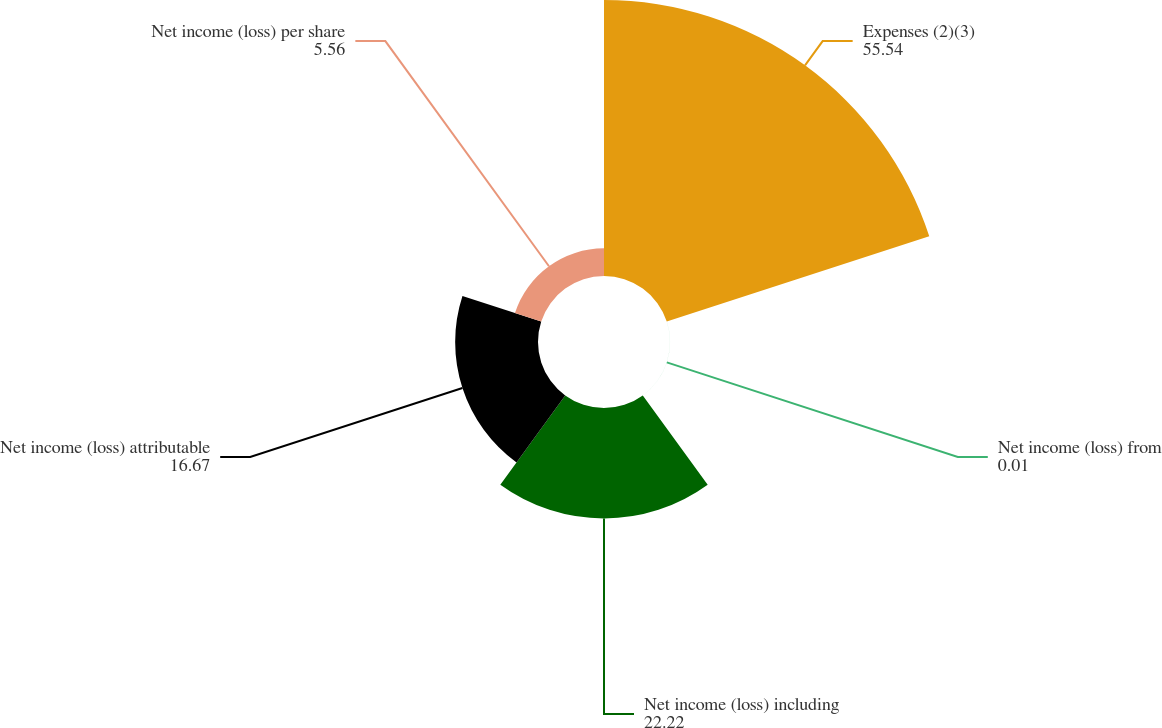Convert chart. <chart><loc_0><loc_0><loc_500><loc_500><pie_chart><fcel>Expenses (2)(3)<fcel>Net income (loss) from<fcel>Net income (loss) including<fcel>Net income (loss) attributable<fcel>Net income (loss) per share<nl><fcel>55.54%<fcel>0.01%<fcel>22.22%<fcel>16.67%<fcel>5.56%<nl></chart> 